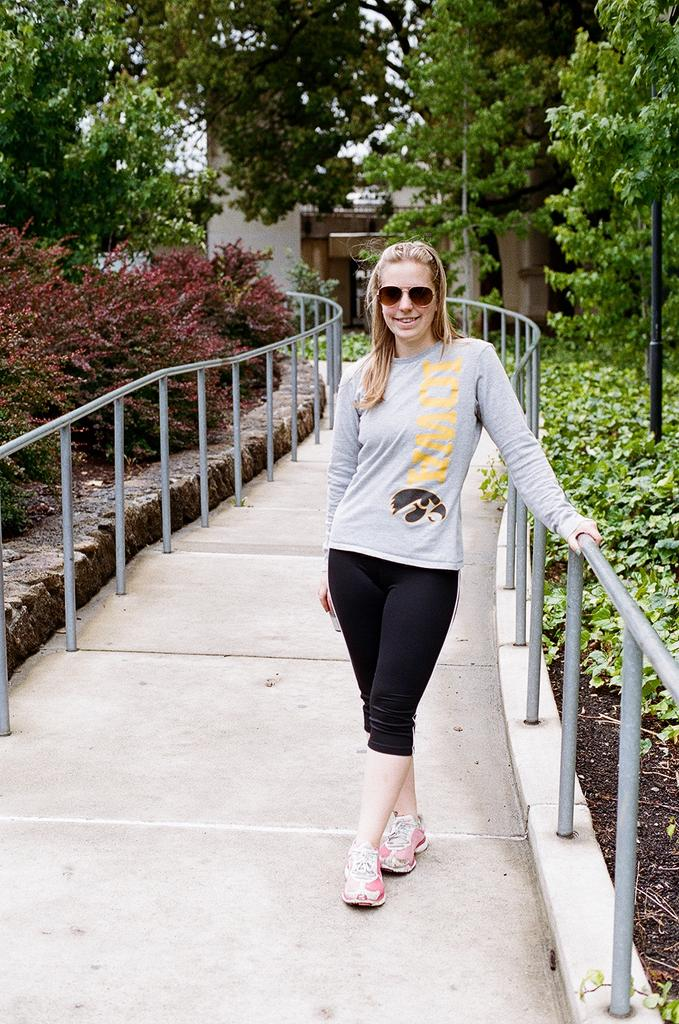Who is present in the image? There is a lady in the image. What is the lady wearing on her face? The lady is wearing spectacles. Where is the lady standing? The lady is standing on the floor. What is located to the side of the lady? There is fencing to the side of the lady. What type of natural environment is visible in the image? There are trees and plants around the area. What type of match is the lady participating in within the image? There is no match or competition present in the image; it simply features a lady standing with spectacles, fencing, and trees and plants in the background. 